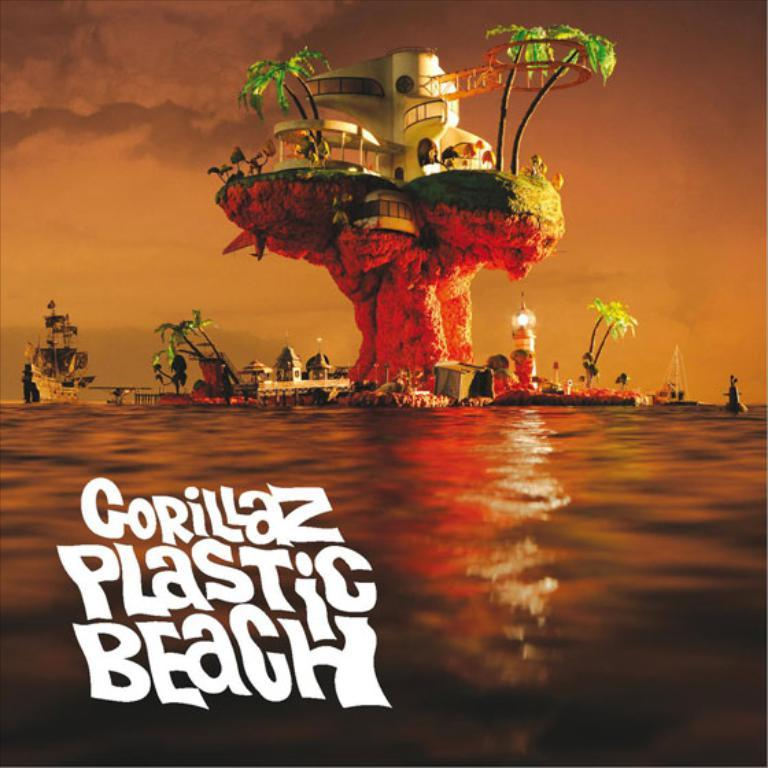What is featured in the image? There is a poster in the image. What is shown on the poster? The poster depicts an island-like structure. What can be found on the island-like structure? The island-like structure has trees. Are there any people depicted on the poster? Yes, there is a person depicted on the poster. What type of dinner is being served on the island in the image? There is no dinner or any indication of food being served in the image; it only features a poster with an island-like structure and a person. 